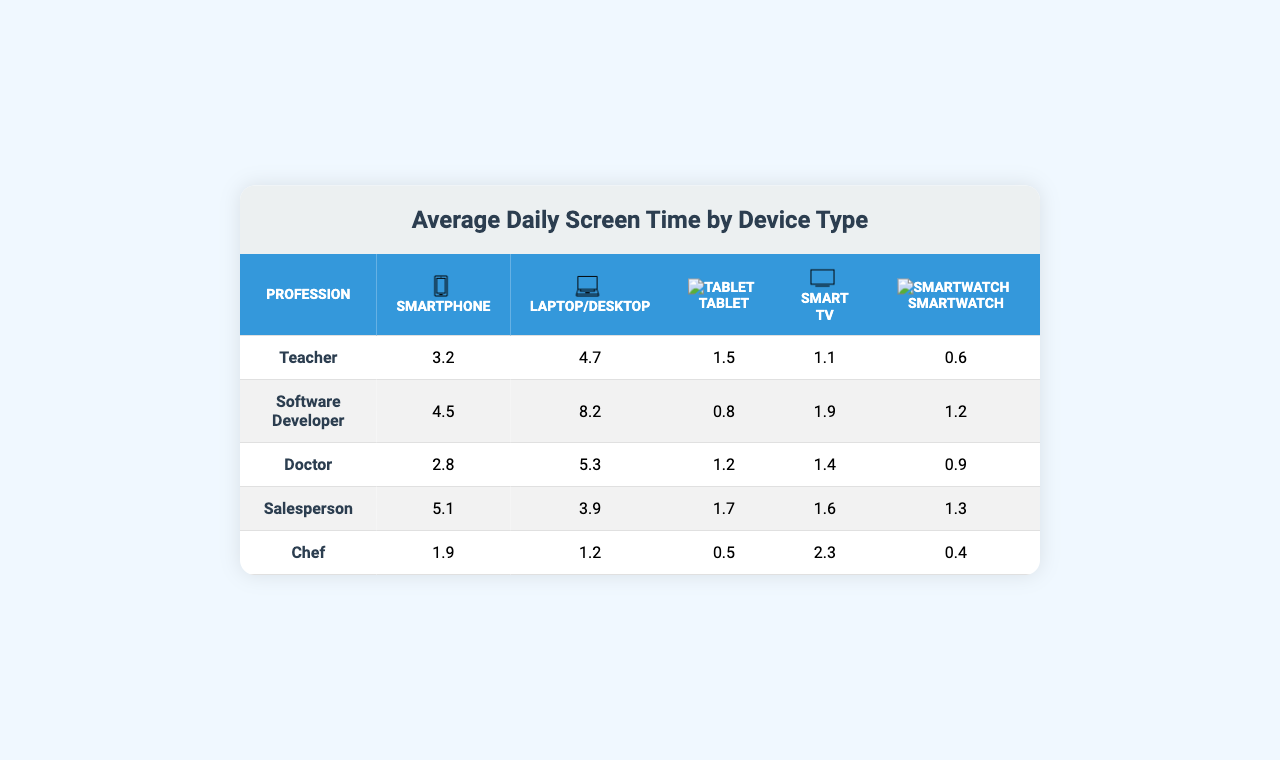What is the average daily screen time on smartphones for teachers? The table shows that teachers spend 3.2 hours daily on smartphones.
Answer: 3.2 hours Which profession has the highest average daily screen time on laptops/desktops? According to the table, software developers have the highest average at 8.2 hours.
Answer: Software Developer What is the average daily screen time for chefs on tablets? The table indicates that chefs spend 0.5 hours daily on tablets.
Answer: 0.5 hours Do doctors spend more time on smart TVs than teachers? The table shows doctors spend 1.4 hours, while teachers spend 1.1 hours. Since 1.4 > 1.1, the statement is true.
Answer: Yes What is the total average daily screen time on all devices for salespeople? For salespeople: Smartphone (5.1) + Laptop/Desktop (3.9) + Tablet (1.7) + Smart TV (1.6) + Smartwatch (1.3) = 13.6 hours.
Answer: 13.6 hours Which profession spends the least amount of time on smartwatches? The table shows that chefs spend the least time on smartwatches at 0.4 hours.
Answer: Chef If we combine the daily screen time on tablets and smartphones for doctors, what is the total? Doctors spend 2.8 hours on smartphones and 1.2 hours on tablets, totaling 2.8 + 1.2 = 4.0 hours.
Answer: 4.0 hours How does the average daily screen time of a software developer on smartphones compare to that of a chef? Software developers spend 4.5 hours, while chefs spend 1.9 hours. Since 4.5 > 1.9, software developers spend more time.
Answer: More Which profession has the least amount of daily screen time overall? Calculating total screen time: Teacher (10.5), Software Developer (15.6), Doctor (11.6), Salesperson (12.1), Chef (6.4). The chef has the least total time, 6.4 hours.
Answer: Chef What is the difference in average daily screen time between the smartphone and laptop/desktop for salespeople? Salespeople spend 5.1 hours on smartphones and 3.9 hours on laptops, the difference is 5.1 - 3.9 = 1.2 hours.
Answer: 1.2 hours 